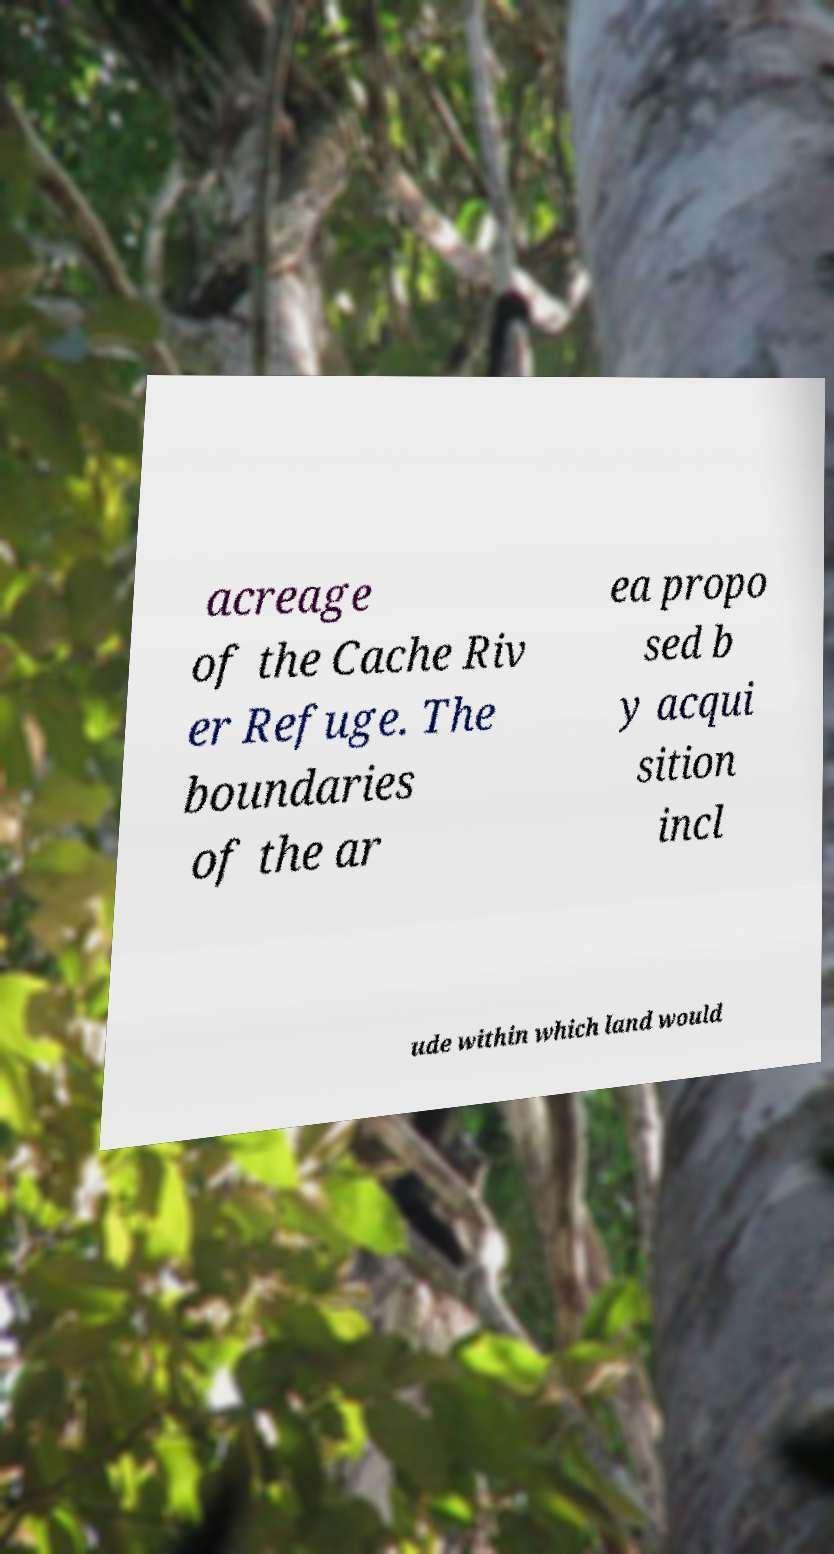There's text embedded in this image that I need extracted. Can you transcribe it verbatim? acreage of the Cache Riv er Refuge. The boundaries of the ar ea propo sed b y acqui sition incl ude within which land would 